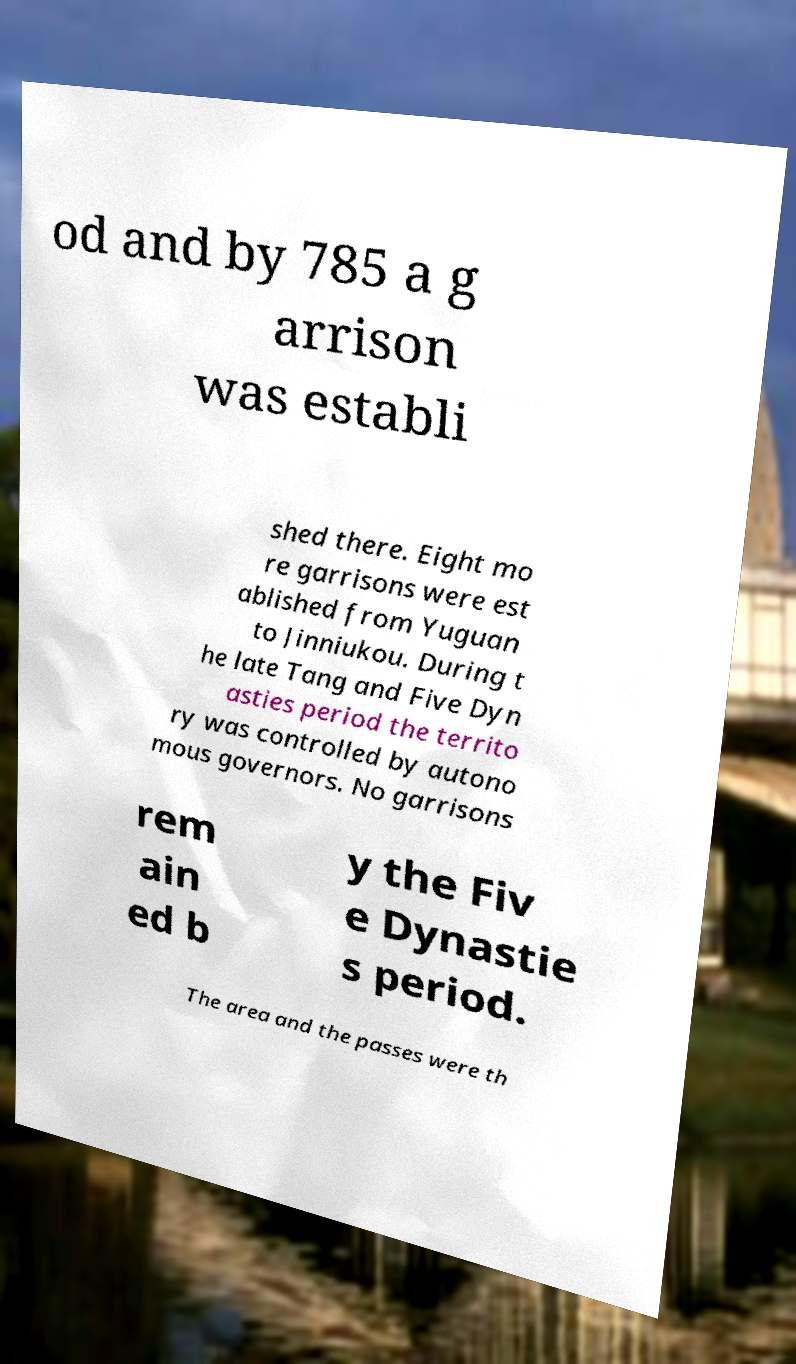Can you accurately transcribe the text from the provided image for me? od and by 785 a g arrison was establi shed there. Eight mo re garrisons were est ablished from Yuguan to Jinniukou. During t he late Tang and Five Dyn asties period the territo ry was controlled by autono mous governors. No garrisons rem ain ed b y the Fiv e Dynastie s period. The area and the passes were th 